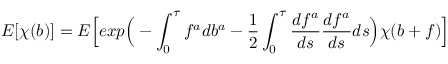Convert formula to latex. <formula><loc_0><loc_0><loc_500><loc_500>E [ \chi ( b ) ] = E \left [ e x p \left ( - \int _ { 0 } ^ { \tau } f ^ { a } d b ^ { a } - \frac { 1 } { 2 } \int _ { 0 } ^ { \tau } \frac { d f ^ { a } } { d s } \frac { d f ^ { a } } { d s } d s \right ) \chi ( b + f ) \right ]</formula> 